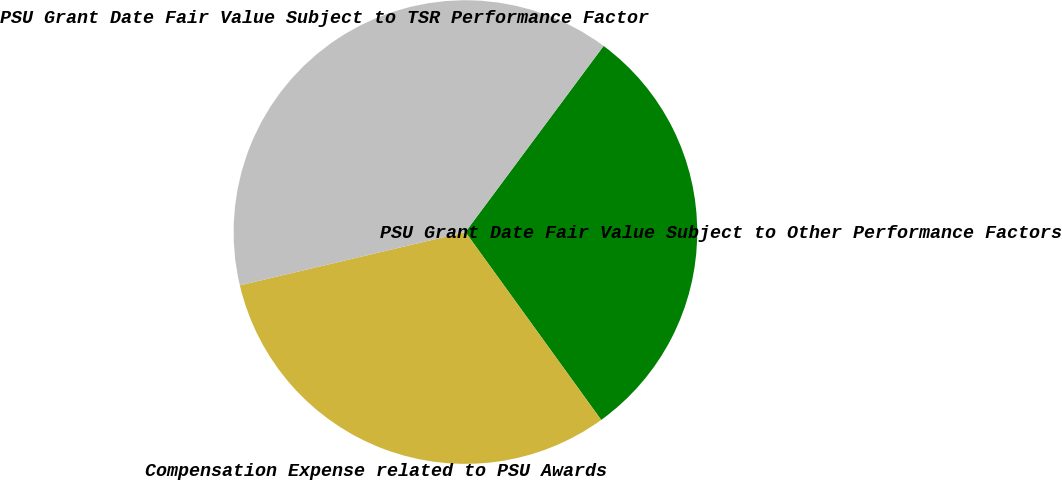<chart> <loc_0><loc_0><loc_500><loc_500><pie_chart><fcel>PSU Grant Date Fair Value Subject to Other Performance Factors<fcel>Compensation Expense related to PSU Awards<fcel>PSU Grant Date Fair Value Subject to TSR Performance Factor<nl><fcel>29.88%<fcel>31.27%<fcel>38.86%<nl></chart> 